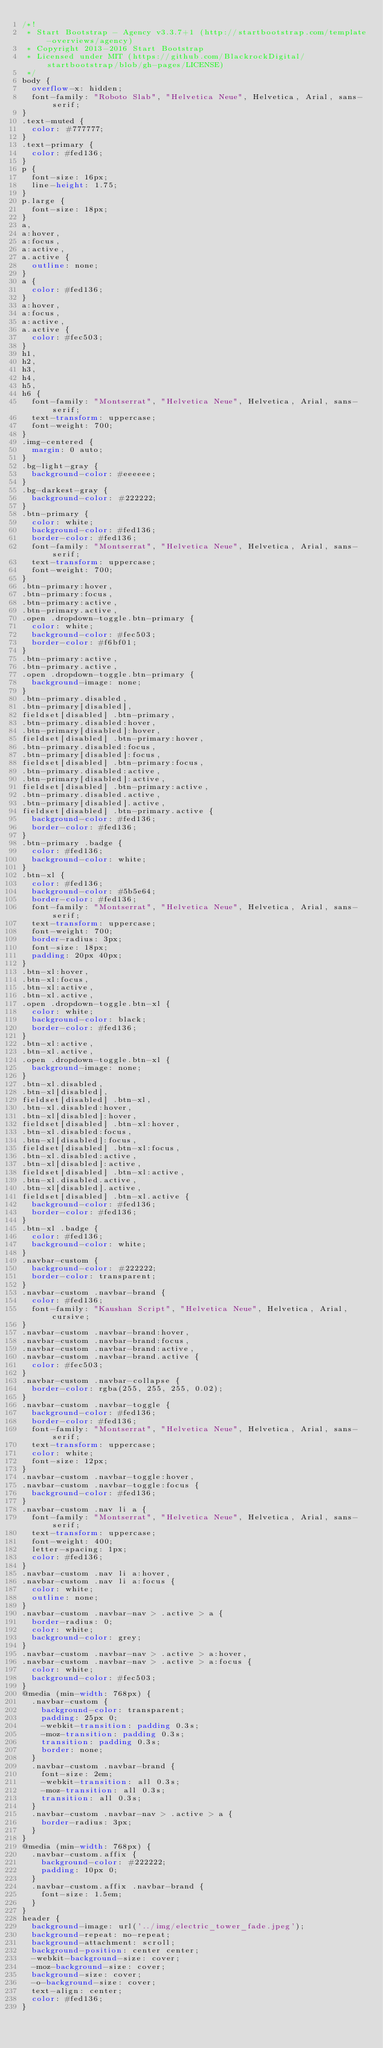Convert code to text. <code><loc_0><loc_0><loc_500><loc_500><_CSS_>/*!
 * Start Bootstrap - Agency v3.3.7+1 (http://startbootstrap.com/template-overviews/agency)
 * Copyright 2013-2016 Start Bootstrap
 * Licensed under MIT (https://github.com/BlackrockDigital/startbootstrap/blob/gh-pages/LICENSE)
 */
body {
  overflow-x: hidden;
  font-family: "Roboto Slab", "Helvetica Neue", Helvetica, Arial, sans-serif;
}
.text-muted {
  color: #777777;
}
.text-primary {
  color: #fed136;
}
p {
  font-size: 16px;
  line-height: 1.75;
}
p.large {
  font-size: 18px;
}
a,
a:hover,
a:focus,
a:active,
a.active {
  outline: none;
}
a {
  color: #fed136;
}
a:hover,
a:focus,
a:active,
a.active {
  color: #fec503;
}
h1,
h2,
h3,
h4,
h5,
h6 {
  font-family: "Montserrat", "Helvetica Neue", Helvetica, Arial, sans-serif;
  text-transform: uppercase;
  font-weight: 700;
}
.img-centered {
  margin: 0 auto;
}
.bg-light-gray {
  background-color: #eeeeee;
}
.bg-darkest-gray {
  background-color: #222222;
}
.btn-primary {
  color: white;
  background-color: #fed136;
  border-color: #fed136;
  font-family: "Montserrat", "Helvetica Neue", Helvetica, Arial, sans-serif;
  text-transform: uppercase;
  font-weight: 700;
}
.btn-primary:hover,
.btn-primary:focus,
.btn-primary:active,
.btn-primary.active,
.open .dropdown-toggle.btn-primary {
  color: white;
  background-color: #fec503;
  border-color: #f6bf01;
}
.btn-primary:active,
.btn-primary.active,
.open .dropdown-toggle.btn-primary {
  background-image: none;
}
.btn-primary.disabled,
.btn-primary[disabled],
fieldset[disabled] .btn-primary,
.btn-primary.disabled:hover,
.btn-primary[disabled]:hover,
fieldset[disabled] .btn-primary:hover,
.btn-primary.disabled:focus,
.btn-primary[disabled]:focus,
fieldset[disabled] .btn-primary:focus,
.btn-primary.disabled:active,
.btn-primary[disabled]:active,
fieldset[disabled] .btn-primary:active,
.btn-primary.disabled.active,
.btn-primary[disabled].active,
fieldset[disabled] .btn-primary.active {
  background-color: #fed136;
  border-color: #fed136;
}
.btn-primary .badge {
  color: #fed136;
  background-color: white;
}
.btn-xl {
  color: #fed136;
  background-color: #5b5e64;
  border-color: #fed136; 
  font-family: "Montserrat", "Helvetica Neue", Helvetica, Arial, sans-serif;
  text-transform: uppercase;
  font-weight: 700;
  border-radius: 3px;
  font-size: 18px;
  padding: 20px 40px;
}
.btn-xl:hover,
.btn-xl:focus,
.btn-xl:active,
.btn-xl.active,
.open .dropdown-toggle.btn-xl {
  color: white;
  background-color: black;
  border-color: #fed136;
}
.btn-xl:active,
.btn-xl.active,
.open .dropdown-toggle.btn-xl {
  background-image: none;
}
.btn-xl.disabled,
.btn-xl[disabled],
fieldset[disabled] .btn-xl,
.btn-xl.disabled:hover,
.btn-xl[disabled]:hover,
fieldset[disabled] .btn-xl:hover,
.btn-xl.disabled:focus,
.btn-xl[disabled]:focus,
fieldset[disabled] .btn-xl:focus,
.btn-xl.disabled:active,
.btn-xl[disabled]:active,
fieldset[disabled] .btn-xl:active,
.btn-xl.disabled.active,
.btn-xl[disabled].active,
fieldset[disabled] .btn-xl.active {
  background-color: #fed136;
  border-color: #fed136;
}
.btn-xl .badge {
  color: #fed136;
  background-color: white;
}
.navbar-custom {
  background-color: #222222;
  border-color: transparent;
}
.navbar-custom .navbar-brand {
  color: #fed136;
  font-family: "Kaushan Script", "Helvetica Neue", Helvetica, Arial, cursive;
}
.navbar-custom .navbar-brand:hover,
.navbar-custom .navbar-brand:focus,
.navbar-custom .navbar-brand:active,
.navbar-custom .navbar-brand.active {
  color: #fec503;
}
.navbar-custom .navbar-collapse {
  border-color: rgba(255, 255, 255, 0.02);
}
.navbar-custom .navbar-toggle {
  background-color: #fed136;
  border-color: #fed136;
  font-family: "Montserrat", "Helvetica Neue", Helvetica, Arial, sans-serif;
  text-transform: uppercase;
  color: white;
  font-size: 12px;
}
.navbar-custom .navbar-toggle:hover,
.navbar-custom .navbar-toggle:focus {
  background-color: #fed136;
}
.navbar-custom .nav li a {
  font-family: "Montserrat", "Helvetica Neue", Helvetica, Arial, sans-serif;
  text-transform: uppercase;
  font-weight: 400;
  letter-spacing: 1px;
  color: #fed136;
}
.navbar-custom .nav li a:hover,
.navbar-custom .nav li a:focus {
  color: white;
  outline: none;
}
.navbar-custom .navbar-nav > .active > a {
  border-radius: 0;
  color: white;
  background-color: grey;
}
.navbar-custom .navbar-nav > .active > a:hover,
.navbar-custom .navbar-nav > .active > a:focus {
  color: white;
  background-color: #fec503;
}
@media (min-width: 768px) {
  .navbar-custom {
    background-color: transparent;
    padding: 25px 0;
    -webkit-transition: padding 0.3s;
    -moz-transition: padding 0.3s;
    transition: padding 0.3s;
    border: none;
  }
  .navbar-custom .navbar-brand {
    font-size: 2em;
    -webkit-transition: all 0.3s;
    -moz-transition: all 0.3s;
    transition: all 0.3s;
  }
  .navbar-custom .navbar-nav > .active > a {
    border-radius: 3px;
  }
}
@media (min-width: 768px) {
  .navbar-custom.affix {
    background-color: #222222;
    padding: 10px 0;
  }
  .navbar-custom.affix .navbar-brand {
    font-size: 1.5em;
  }
}
header {
  background-image: url('../img/electric_tower_fade.jpeg');
  background-repeat: no-repeat;
  background-attachment: scroll;
  background-position: center center;
  -webkit-background-size: cover;
  -moz-background-size: cover;
  background-size: cover;
  -o-background-size: cover;
  text-align: center;
  color: #fed136;
}

</code> 